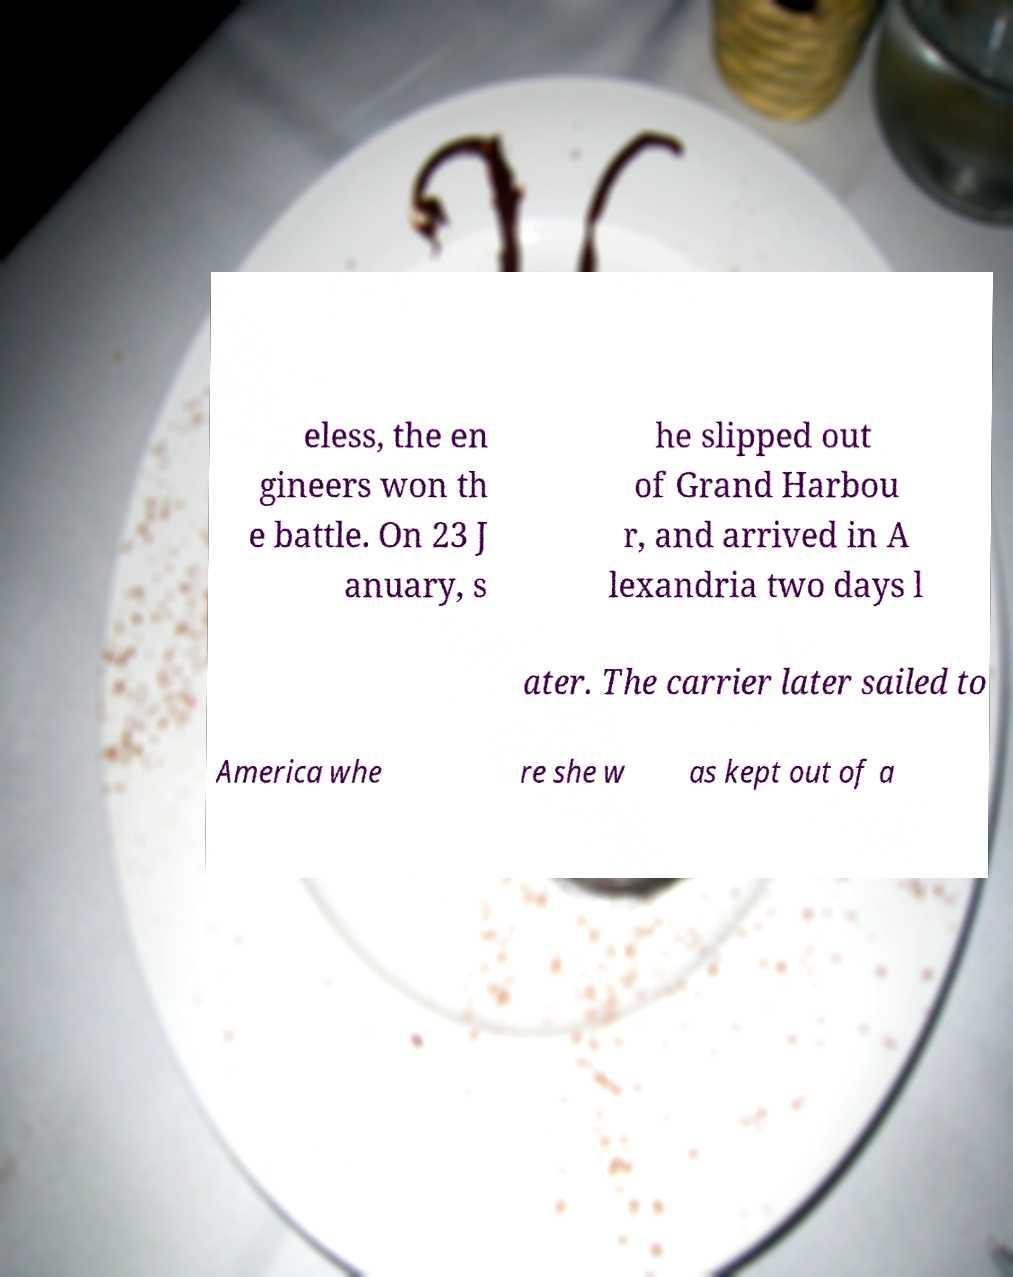There's text embedded in this image that I need extracted. Can you transcribe it verbatim? eless, the en gineers won th e battle. On 23 J anuary, s he slipped out of Grand Harbou r, and arrived in A lexandria two days l ater. The carrier later sailed to America whe re she w as kept out of a 